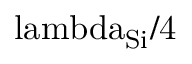<formula> <loc_0><loc_0><loc_500><loc_500>\ l a m b d a _ { S i } / 4</formula> 